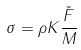<formula> <loc_0><loc_0><loc_500><loc_500>\sigma = \rho K \frac { \tilde { F } } { M }</formula> 